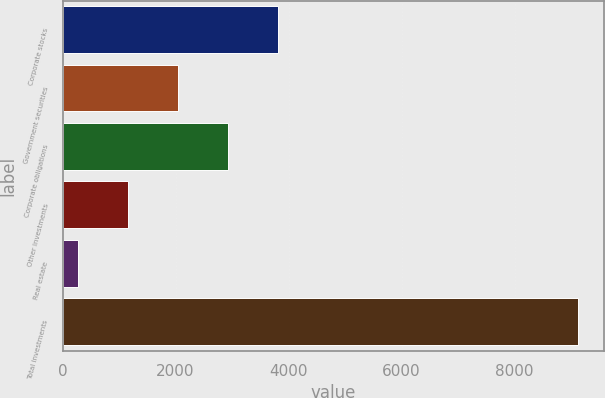<chart> <loc_0><loc_0><loc_500><loc_500><bar_chart><fcel>Corporate stocks<fcel>Government securities<fcel>Corporate obligations<fcel>Other investments<fcel>Real estate<fcel>Total investments<nl><fcel>3816.8<fcel>2046.4<fcel>2931.6<fcel>1161.2<fcel>276<fcel>9128<nl></chart> 